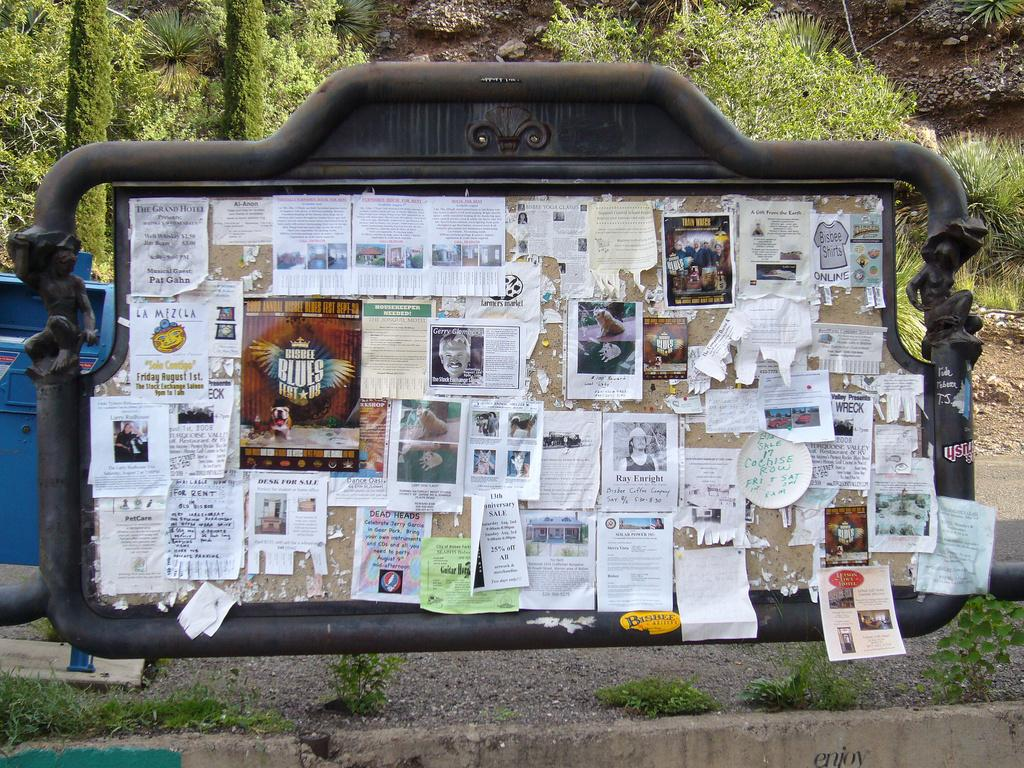What is the main object in the image? There is a board in the image. What is on the board? There are posters on the board. What can be seen in the background of the image? There is a dustbin and trees in the background of the image. What type of surface is visible at the bottom of the image? There is land visible at the bottom of the image. Can you see a rabbit hopping on the land in the image? There is no rabbit visible in the image; only the board, posters, dustbin, trees, and land can be seen. How much does the quarter cost in the image? There is no mention of a quarter or any currency in the image. 